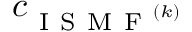Convert formula to latex. <formula><loc_0><loc_0><loc_500><loc_500>c _ { I S M F ^ { ( k ) } }</formula> 